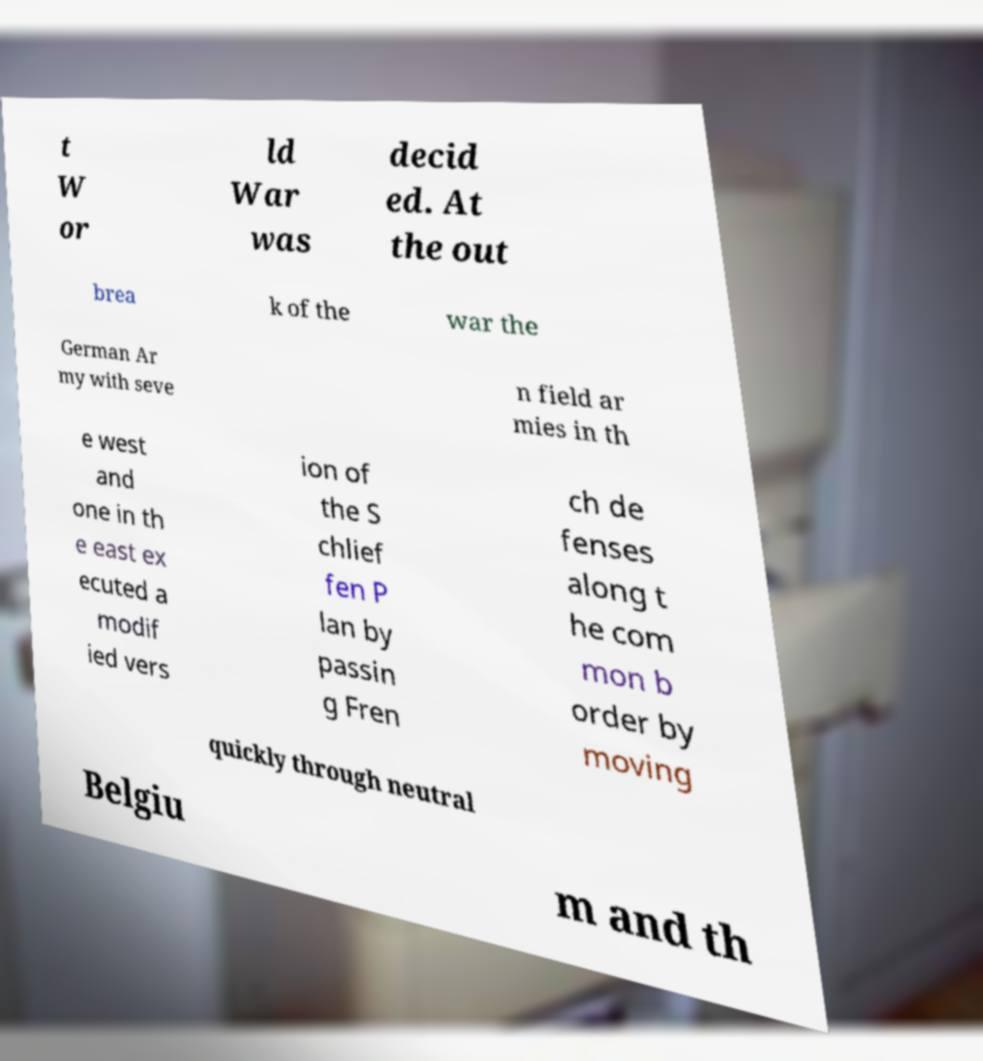Please identify and transcribe the text found in this image. t W or ld War was decid ed. At the out brea k of the war the German Ar my with seve n field ar mies in th e west and one in th e east ex ecuted a modif ied vers ion of the S chlief fen P lan by passin g Fren ch de fenses along t he com mon b order by moving quickly through neutral Belgiu m and th 